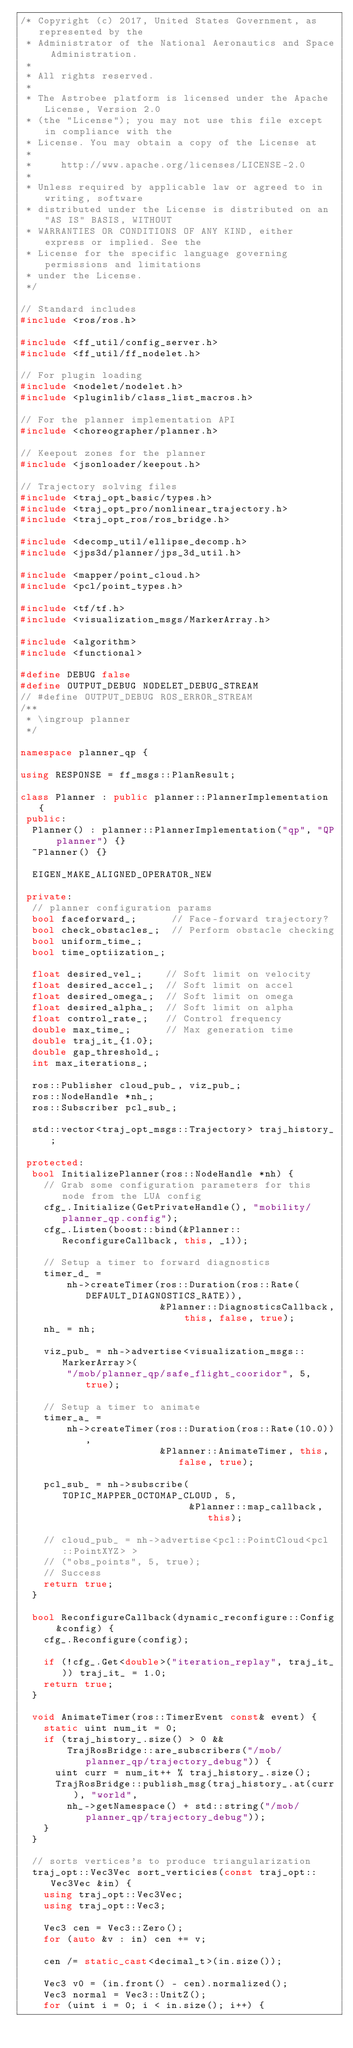<code> <loc_0><loc_0><loc_500><loc_500><_C++_>/* Copyright (c) 2017, United States Government, as represented by the
 * Administrator of the National Aeronautics and Space Administration.
 *
 * All rights reserved.
 *
 * The Astrobee platform is licensed under the Apache License, Version 2.0
 * (the "License"); you may not use this file except in compliance with the
 * License. You may obtain a copy of the License at
 *
 *     http://www.apache.org/licenses/LICENSE-2.0
 *
 * Unless required by applicable law or agreed to in writing, software
 * distributed under the License is distributed on an "AS IS" BASIS, WITHOUT
 * WARRANTIES OR CONDITIONS OF ANY KIND, either express or implied. See the
 * License for the specific language governing permissions and limitations
 * under the License.
 */

// Standard includes
#include <ros/ros.h>

#include <ff_util/config_server.h>
#include <ff_util/ff_nodelet.h>

// For plugin loading
#include <nodelet/nodelet.h>
#include <pluginlib/class_list_macros.h>

// For the planner implementation API
#include <choreographer/planner.h>

// Keepout zones for the planner
#include <jsonloader/keepout.h>

// Trajectory solving files
#include <traj_opt_basic/types.h>
#include <traj_opt_pro/nonlinear_trajectory.h>
#include <traj_opt_ros/ros_bridge.h>

#include <decomp_util/ellipse_decomp.h>
#include <jps3d/planner/jps_3d_util.h>

#include <mapper/point_cloud.h>
#include <pcl/point_types.h>

#include <tf/tf.h>
#include <visualization_msgs/MarkerArray.h>

#include <algorithm>
#include <functional>

#define DEBUG false
#define OUTPUT_DEBUG NODELET_DEBUG_STREAM
// #define OUTPUT_DEBUG ROS_ERROR_STREAM
/**
 * \ingroup planner
 */

namespace planner_qp {

using RESPONSE = ff_msgs::PlanResult;

class Planner : public planner::PlannerImplementation {
 public:
  Planner() : planner::PlannerImplementation("qp", "QP planner") {}
  ~Planner() {}

  EIGEN_MAKE_ALIGNED_OPERATOR_NEW

 private:
  // planner configuration params
  bool faceforward_;      // Face-forward trajectory?
  bool check_obstacles_;  // Perform obstacle checking
  bool uniform_time_;
  bool time_optiization_;

  float desired_vel_;    // Soft limit on velocity
  float desired_accel_;  // Soft limit on accel
  float desired_omega_;  // Soft limit on omega
  float desired_alpha_;  // Soft limit on alpha
  float control_rate_;   // Control frequency
  double max_time_;      // Max generation time
  double traj_it_{1.0};
  double gap_threshold_;
  int max_iterations_;

  ros::Publisher cloud_pub_, viz_pub_;
  ros::NodeHandle *nh_;
  ros::Subscriber pcl_sub_;

  std::vector<traj_opt_msgs::Trajectory> traj_history_;

 protected:
  bool InitializePlanner(ros::NodeHandle *nh) {
    // Grab some configuration parameters for this node from the LUA config
    cfg_.Initialize(GetPrivateHandle(), "mobility/planner_qp.config");
    cfg_.Listen(boost::bind(&Planner::ReconfigureCallback, this, _1));

    // Setup a timer to forward diagnostics
    timer_d_ =
        nh->createTimer(ros::Duration(ros::Rate(DEFAULT_DIAGNOSTICS_RATE)),
                        &Planner::DiagnosticsCallback, this, false, true);
    nh_ = nh;

    viz_pub_ = nh->advertise<visualization_msgs::MarkerArray>(
        "/mob/planner_qp/safe_flight_cooridor", 5, true);

    // Setup a timer to animate
    timer_a_ =
        nh->createTimer(ros::Duration(ros::Rate(10.0)),
                        &Planner::AnimateTimer, this, false, true);

    pcl_sub_ = nh->subscribe(TOPIC_MAPPER_OCTOMAP_CLOUD, 5,
                             &Planner::map_callback, this);

    // cloud_pub_ = nh->advertise<pcl::PointCloud<pcl::PointXYZ> >
    // ("obs_points", 5, true);
    // Success
    return true;
  }

  bool ReconfigureCallback(dynamic_reconfigure::Config &config) {
    cfg_.Reconfigure(config);

    if (!cfg_.Get<double>("iteration_replay", traj_it_)) traj_it_ = 1.0;
    return true;
  }

  void AnimateTimer(ros::TimerEvent const& event) {
    static uint num_it = 0;
    if (traj_history_.size() > 0 &&
        TrajRosBridge::are_subscribers("/mob/planner_qp/trajectory_debug")) {
      uint curr = num_it++ % traj_history_.size();
      TrajRosBridge::publish_msg(traj_history_.at(curr), "world",
        nh_->getNamespace() + std::string("/mob/planner_qp/trajectory_debug"));
    }
  }

  // sorts vertices's to produce triangularization
  traj_opt::Vec3Vec sort_verticies(const traj_opt::Vec3Vec &in) {
    using traj_opt::Vec3Vec;
    using traj_opt::Vec3;

    Vec3 cen = Vec3::Zero();
    for (auto &v : in) cen += v;

    cen /= static_cast<decimal_t>(in.size());

    Vec3 v0 = (in.front() - cen).normalized();
    Vec3 normal = Vec3::UnitZ();
    for (uint i = 0; i < in.size(); i++) {</code> 